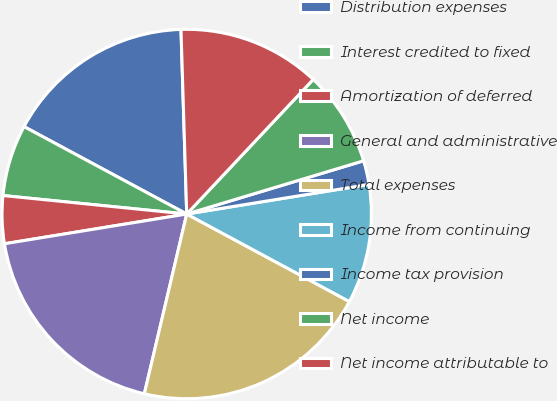<chart> <loc_0><loc_0><loc_500><loc_500><pie_chart><fcel>Distribution expenses<fcel>Interest credited to fixed<fcel>Amortization of deferred<fcel>General and administrative<fcel>Total expenses<fcel>Income from continuing<fcel>Income tax provision<fcel>Net income<fcel>Net income attributable to<nl><fcel>16.66%<fcel>6.25%<fcel>4.17%<fcel>18.74%<fcel>20.83%<fcel>10.42%<fcel>2.09%<fcel>8.34%<fcel>12.5%<nl></chart> 